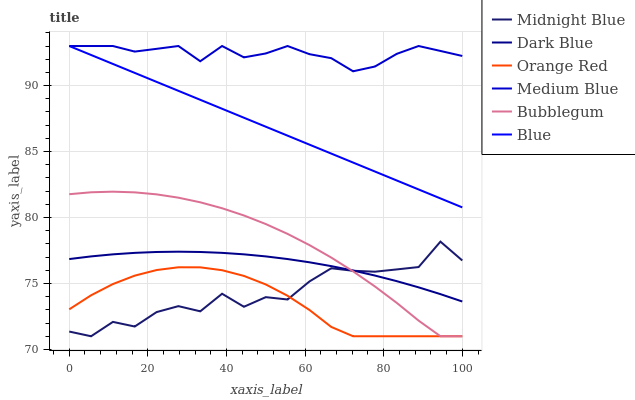Does Orange Red have the minimum area under the curve?
Answer yes or no. Yes. Does Medium Blue have the maximum area under the curve?
Answer yes or no. Yes. Does Midnight Blue have the minimum area under the curve?
Answer yes or no. No. Does Midnight Blue have the maximum area under the curve?
Answer yes or no. No. Is Blue the smoothest?
Answer yes or no. Yes. Is Midnight Blue the roughest?
Answer yes or no. Yes. Is Medium Blue the smoothest?
Answer yes or no. No. Is Medium Blue the roughest?
Answer yes or no. No. Does Midnight Blue have the lowest value?
Answer yes or no. Yes. Does Medium Blue have the lowest value?
Answer yes or no. No. Does Medium Blue have the highest value?
Answer yes or no. Yes. Does Midnight Blue have the highest value?
Answer yes or no. No. Is Midnight Blue less than Blue?
Answer yes or no. Yes. Is Dark Blue greater than Orange Red?
Answer yes or no. Yes. Does Bubblegum intersect Midnight Blue?
Answer yes or no. Yes. Is Bubblegum less than Midnight Blue?
Answer yes or no. No. Is Bubblegum greater than Midnight Blue?
Answer yes or no. No. Does Midnight Blue intersect Blue?
Answer yes or no. No. 